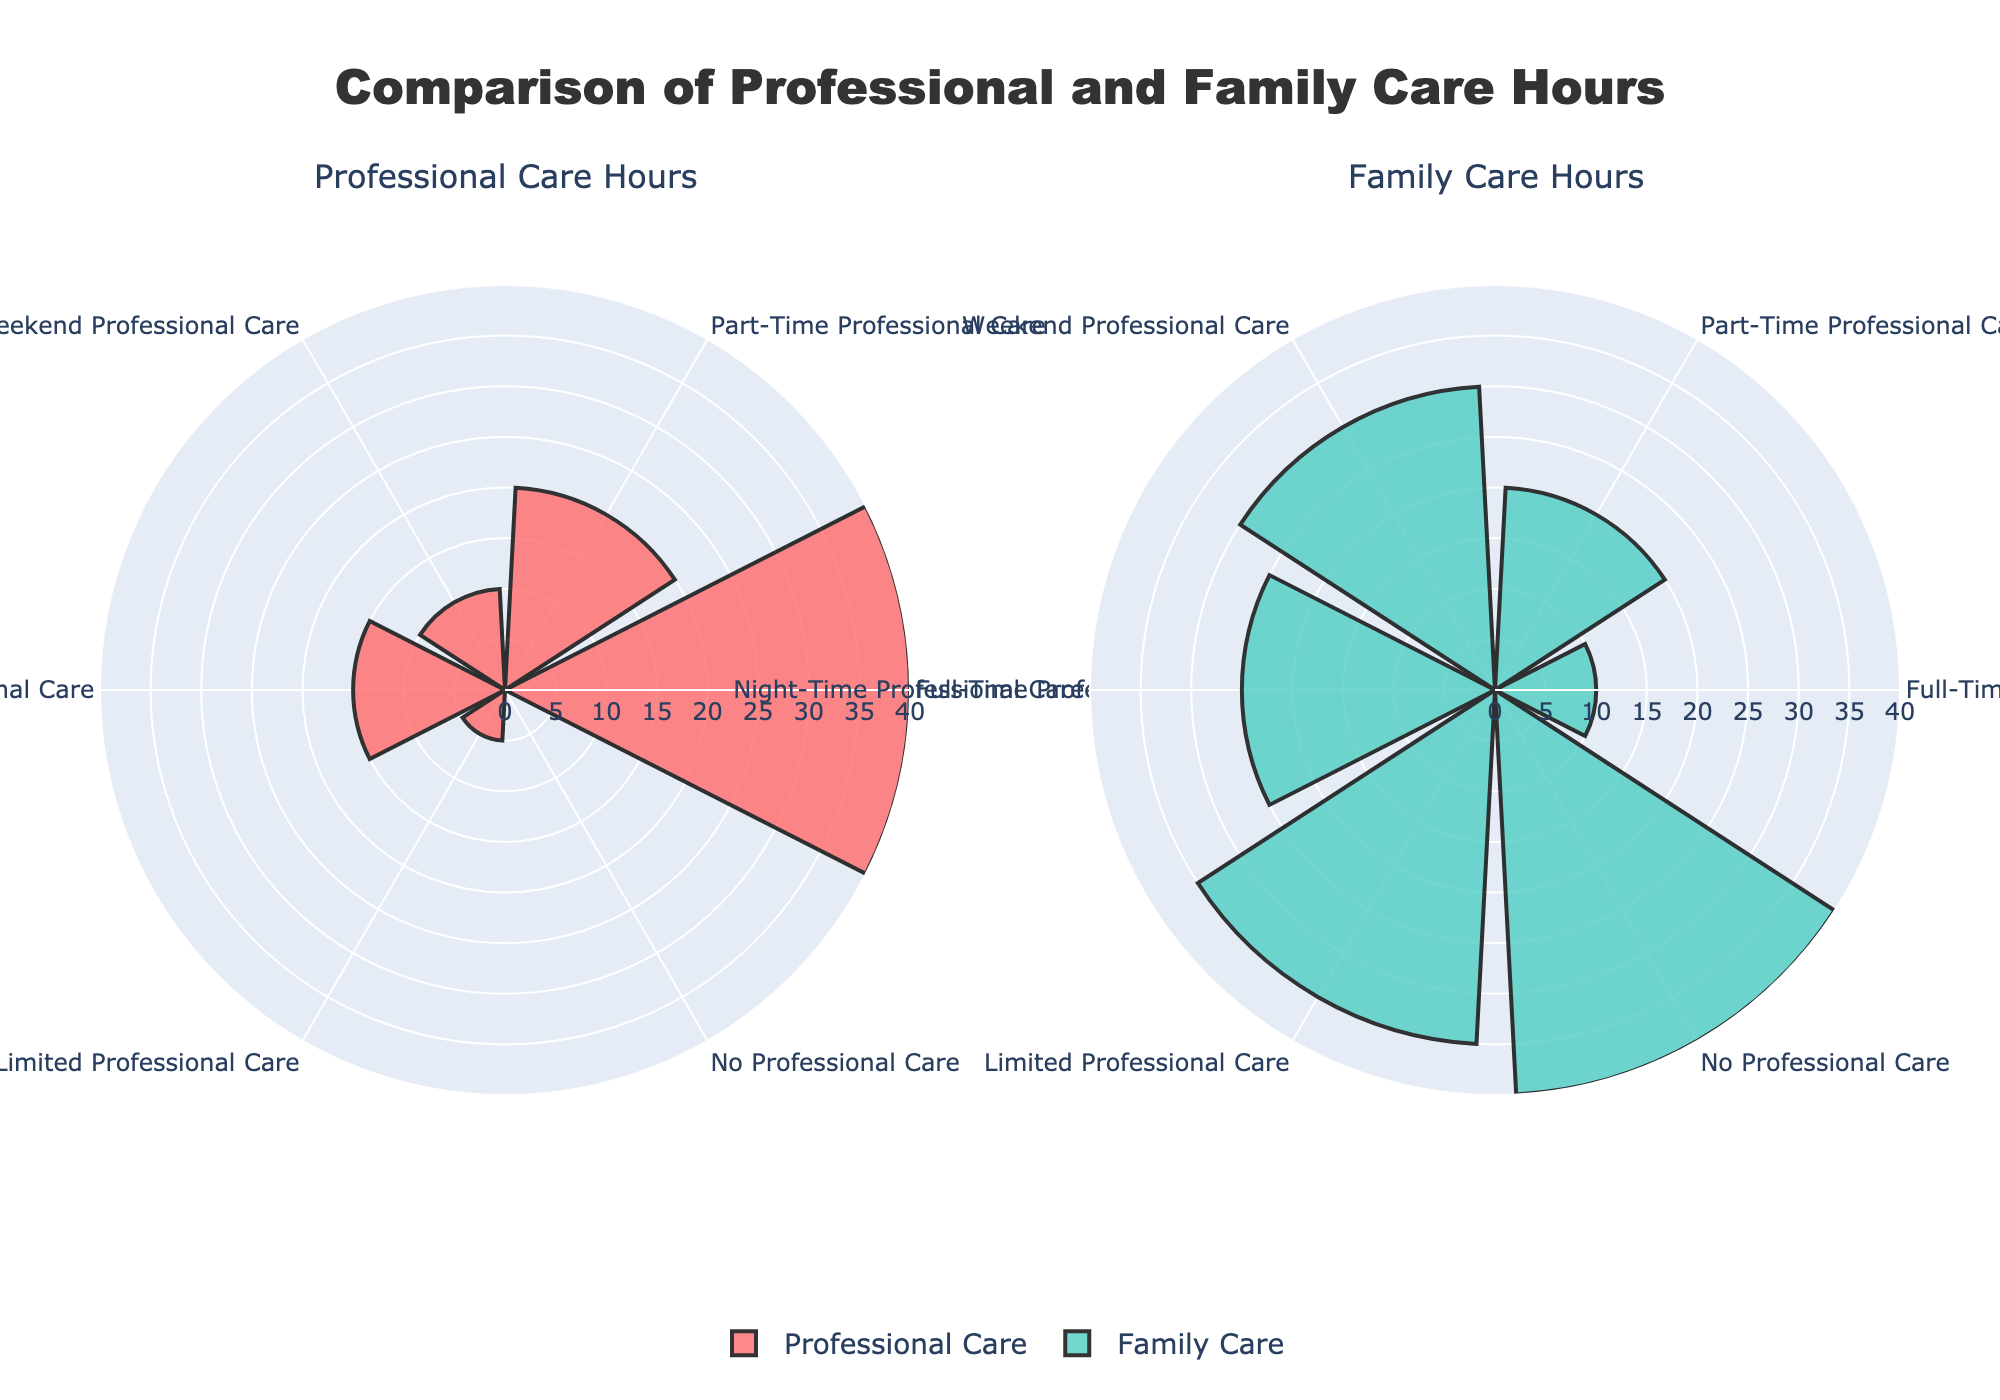How many caregiving categories are shown in the figure? There are six distinct caregiving categories visible in the figure: Full-Time Professional Care, Part-Time Professional Care, Weekend Professional Care, Night-Time Professional Care, Limited Professional Care, and No Professional Care.
Answer: Six What is the title of the figure? The title of the figure is "Comparison of Professional and Family Care Hours."
Answer: Comparison of Professional and Family Care Hours Which caregiving category has the highest number of family caregiving hours? By looking at the subplot for Family Care Hours, the caregiving category with the highest number of family caregiving hours is "No Professional Care," which shows 40 family care hours.
Answer: No Professional Care Which caregiving category shows the same number of professional care and family care hours? In the figure, the caregiving category "Part-Time Professional Care" has equal professional and family care hours, each having 20 hours.
Answer: Part-Time Professional Care What is the total number of professional care hours for all categories combined? The sum of professional care hours is calculated by adding the values of all caregiving categories: 40 (Full-Time) + 20 (Part-Time) + 10 (Weekend) + 15 (Night-Time) + 5 (Limited) + 0 (No Care) = 90 hours.
Answer: 90 hours Which caregiving category requires more family caregiving hours than professional caregiving hours? Categories where family caregiving hours exceed professional caregiving hours include: Weekend Professional Care, Night-Time Professional Care, Limited Professional Care, and No Professional Care.
Answer: Weekend Professional Care, Night-Time Professional Care, Limited Professional Care, No Professional Care What is the average number of professional care hours across all categories? First, find the total professional care hours (90), then divide by the number of categories (6): 90 / 6 = 15 hours.
Answer: 15 hours In which caregiving category is professional care most dominant compared to family care? By comparing the two subplots, the "Full-Time Professional Care" category has the highest professional care hours (40) relative to family care hours (10), showing the most dominant professional care.
Answer: Full-Time Professional Care How many categories have more than 20 family care hours per week? By referring to the Family Care Hours subplot, categories with more than 20 family care hours include: Weekend Professional Care (30 hours), Night-Time Professional Care (25 hours), Limited Professional Care (35 hours), and No Professional Care (40 hours).
Answer: Four Which caregiving category has the smallest number of professional care hours? The caregiving category with the smallest number of professional care hours is "No Professional Care," with 0 hours.
Answer: No Professional Care 